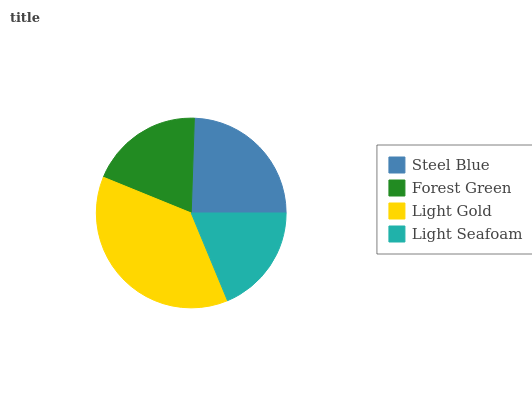Is Light Seafoam the minimum?
Answer yes or no. Yes. Is Light Gold the maximum?
Answer yes or no. Yes. Is Forest Green the minimum?
Answer yes or no. No. Is Forest Green the maximum?
Answer yes or no. No. Is Steel Blue greater than Forest Green?
Answer yes or no. Yes. Is Forest Green less than Steel Blue?
Answer yes or no. Yes. Is Forest Green greater than Steel Blue?
Answer yes or no. No. Is Steel Blue less than Forest Green?
Answer yes or no. No. Is Steel Blue the high median?
Answer yes or no. Yes. Is Forest Green the low median?
Answer yes or no. Yes. Is Light Seafoam the high median?
Answer yes or no. No. Is Light Gold the low median?
Answer yes or no. No. 